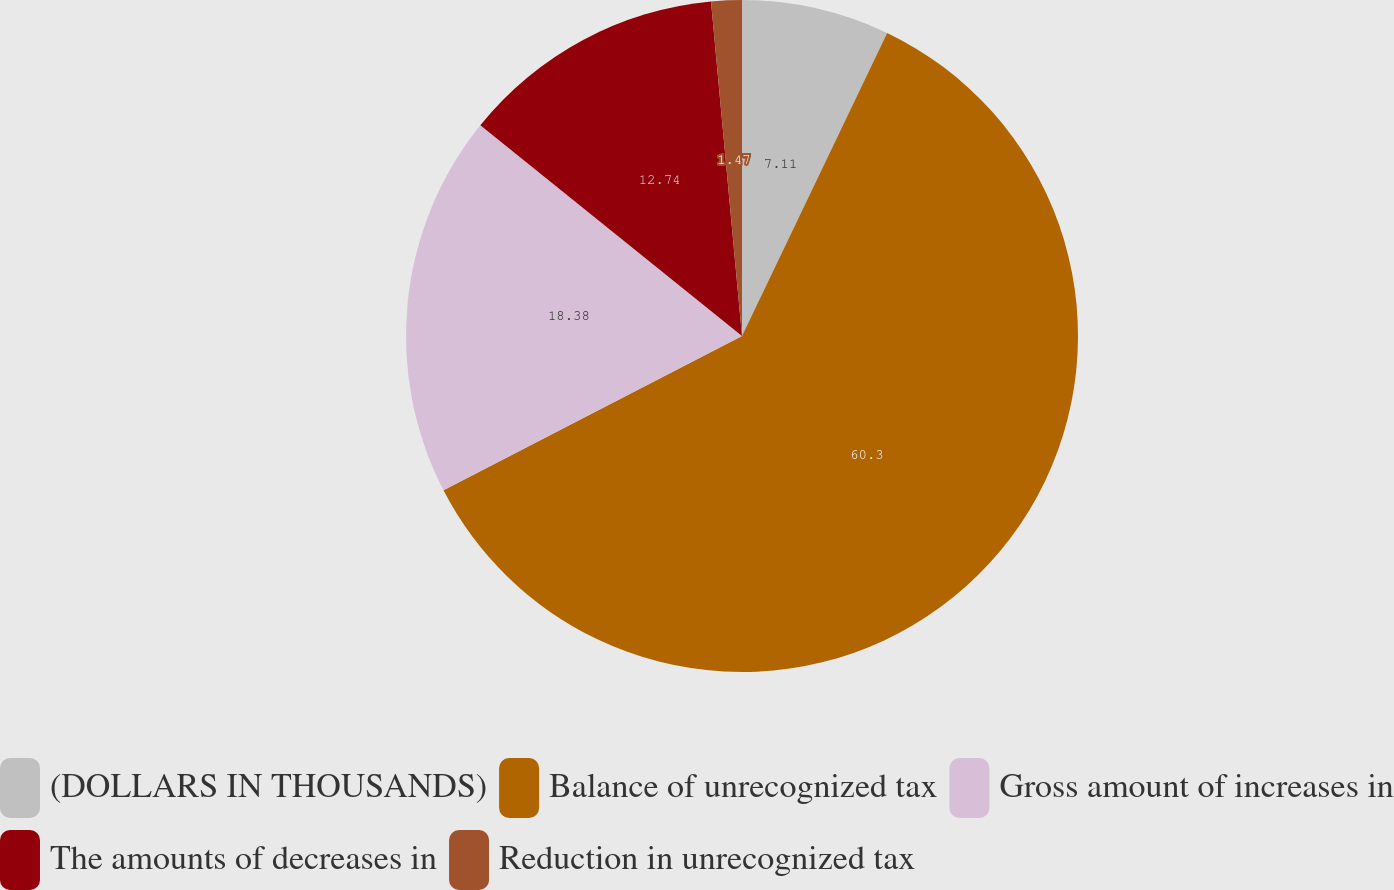Convert chart. <chart><loc_0><loc_0><loc_500><loc_500><pie_chart><fcel>(DOLLARS IN THOUSANDS)<fcel>Balance of unrecognized tax<fcel>Gross amount of increases in<fcel>The amounts of decreases in<fcel>Reduction in unrecognized tax<nl><fcel>7.11%<fcel>60.3%<fcel>18.38%<fcel>12.74%<fcel>1.47%<nl></chart> 